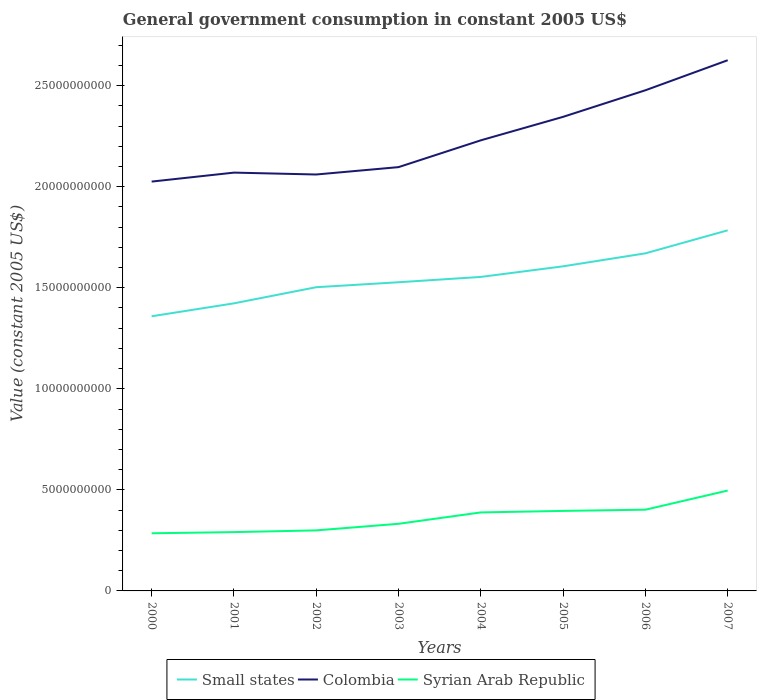How many different coloured lines are there?
Provide a short and direct response. 3. Does the line corresponding to Syrian Arab Republic intersect with the line corresponding to Small states?
Ensure brevity in your answer.  No. Across all years, what is the maximum government conusmption in Small states?
Your answer should be compact. 1.36e+1. What is the total government conusmption in Syrian Arab Republic in the graph?
Keep it short and to the point. -1.35e+08. What is the difference between the highest and the second highest government conusmption in Colombia?
Make the answer very short. 6.00e+09. What is the difference between the highest and the lowest government conusmption in Syrian Arab Republic?
Your answer should be very brief. 4. Is the government conusmption in Syrian Arab Republic strictly greater than the government conusmption in Colombia over the years?
Offer a terse response. Yes. What is the difference between two consecutive major ticks on the Y-axis?
Ensure brevity in your answer.  5.00e+09. Does the graph contain any zero values?
Your response must be concise. No. Does the graph contain grids?
Keep it short and to the point. No. Where does the legend appear in the graph?
Offer a terse response. Bottom center. How many legend labels are there?
Your response must be concise. 3. How are the legend labels stacked?
Ensure brevity in your answer.  Horizontal. What is the title of the graph?
Offer a very short reply. General government consumption in constant 2005 US$. Does "Germany" appear as one of the legend labels in the graph?
Provide a short and direct response. No. What is the label or title of the X-axis?
Offer a terse response. Years. What is the label or title of the Y-axis?
Your answer should be very brief. Value (constant 2005 US$). What is the Value (constant 2005 US$) in Small states in 2000?
Provide a succinct answer. 1.36e+1. What is the Value (constant 2005 US$) in Colombia in 2000?
Your answer should be very brief. 2.03e+1. What is the Value (constant 2005 US$) of Syrian Arab Republic in 2000?
Offer a very short reply. 2.85e+09. What is the Value (constant 2005 US$) of Small states in 2001?
Offer a very short reply. 1.42e+1. What is the Value (constant 2005 US$) of Colombia in 2001?
Provide a succinct answer. 2.07e+1. What is the Value (constant 2005 US$) in Syrian Arab Republic in 2001?
Offer a terse response. 2.91e+09. What is the Value (constant 2005 US$) of Small states in 2002?
Offer a terse response. 1.50e+1. What is the Value (constant 2005 US$) of Colombia in 2002?
Make the answer very short. 2.06e+1. What is the Value (constant 2005 US$) of Syrian Arab Republic in 2002?
Ensure brevity in your answer.  2.99e+09. What is the Value (constant 2005 US$) of Small states in 2003?
Give a very brief answer. 1.53e+1. What is the Value (constant 2005 US$) of Colombia in 2003?
Your answer should be very brief. 2.10e+1. What is the Value (constant 2005 US$) in Syrian Arab Republic in 2003?
Your response must be concise. 3.32e+09. What is the Value (constant 2005 US$) in Small states in 2004?
Your answer should be very brief. 1.55e+1. What is the Value (constant 2005 US$) of Colombia in 2004?
Provide a short and direct response. 2.23e+1. What is the Value (constant 2005 US$) of Syrian Arab Republic in 2004?
Ensure brevity in your answer.  3.88e+09. What is the Value (constant 2005 US$) of Small states in 2005?
Make the answer very short. 1.61e+1. What is the Value (constant 2005 US$) in Colombia in 2005?
Provide a succinct answer. 2.35e+1. What is the Value (constant 2005 US$) in Syrian Arab Republic in 2005?
Your answer should be very brief. 3.96e+09. What is the Value (constant 2005 US$) of Small states in 2006?
Provide a short and direct response. 1.67e+1. What is the Value (constant 2005 US$) of Colombia in 2006?
Provide a succinct answer. 2.48e+1. What is the Value (constant 2005 US$) of Syrian Arab Republic in 2006?
Keep it short and to the point. 4.02e+09. What is the Value (constant 2005 US$) in Small states in 2007?
Give a very brief answer. 1.78e+1. What is the Value (constant 2005 US$) of Colombia in 2007?
Provide a short and direct response. 2.63e+1. What is the Value (constant 2005 US$) of Syrian Arab Republic in 2007?
Your answer should be very brief. 4.97e+09. Across all years, what is the maximum Value (constant 2005 US$) in Small states?
Offer a very short reply. 1.78e+1. Across all years, what is the maximum Value (constant 2005 US$) of Colombia?
Keep it short and to the point. 2.63e+1. Across all years, what is the maximum Value (constant 2005 US$) in Syrian Arab Republic?
Your answer should be compact. 4.97e+09. Across all years, what is the minimum Value (constant 2005 US$) of Small states?
Give a very brief answer. 1.36e+1. Across all years, what is the minimum Value (constant 2005 US$) of Colombia?
Your answer should be compact. 2.03e+1. Across all years, what is the minimum Value (constant 2005 US$) of Syrian Arab Republic?
Make the answer very short. 2.85e+09. What is the total Value (constant 2005 US$) of Small states in the graph?
Provide a short and direct response. 1.24e+11. What is the total Value (constant 2005 US$) of Colombia in the graph?
Keep it short and to the point. 1.79e+11. What is the total Value (constant 2005 US$) in Syrian Arab Republic in the graph?
Provide a succinct answer. 2.89e+1. What is the difference between the Value (constant 2005 US$) of Small states in 2000 and that in 2001?
Make the answer very short. -6.40e+08. What is the difference between the Value (constant 2005 US$) of Colombia in 2000 and that in 2001?
Your answer should be compact. -4.44e+08. What is the difference between the Value (constant 2005 US$) in Syrian Arab Republic in 2000 and that in 2001?
Provide a succinct answer. -5.79e+07. What is the difference between the Value (constant 2005 US$) in Small states in 2000 and that in 2002?
Offer a very short reply. -1.44e+09. What is the difference between the Value (constant 2005 US$) in Colombia in 2000 and that in 2002?
Provide a succinct answer. -3.51e+08. What is the difference between the Value (constant 2005 US$) in Syrian Arab Republic in 2000 and that in 2002?
Ensure brevity in your answer.  -1.43e+08. What is the difference between the Value (constant 2005 US$) in Small states in 2000 and that in 2003?
Keep it short and to the point. -1.68e+09. What is the difference between the Value (constant 2005 US$) in Colombia in 2000 and that in 2003?
Give a very brief answer. -7.15e+08. What is the difference between the Value (constant 2005 US$) in Syrian Arab Republic in 2000 and that in 2003?
Ensure brevity in your answer.  -4.69e+08. What is the difference between the Value (constant 2005 US$) in Small states in 2000 and that in 2004?
Provide a short and direct response. -1.95e+09. What is the difference between the Value (constant 2005 US$) of Colombia in 2000 and that in 2004?
Provide a succinct answer. -2.04e+09. What is the difference between the Value (constant 2005 US$) of Syrian Arab Republic in 2000 and that in 2004?
Your answer should be compact. -1.03e+09. What is the difference between the Value (constant 2005 US$) of Small states in 2000 and that in 2005?
Ensure brevity in your answer.  -2.47e+09. What is the difference between the Value (constant 2005 US$) of Colombia in 2000 and that in 2005?
Your answer should be very brief. -3.20e+09. What is the difference between the Value (constant 2005 US$) in Syrian Arab Republic in 2000 and that in 2005?
Give a very brief answer. -1.11e+09. What is the difference between the Value (constant 2005 US$) of Small states in 2000 and that in 2006?
Ensure brevity in your answer.  -3.11e+09. What is the difference between the Value (constant 2005 US$) in Colombia in 2000 and that in 2006?
Keep it short and to the point. -4.52e+09. What is the difference between the Value (constant 2005 US$) in Syrian Arab Republic in 2000 and that in 2006?
Your response must be concise. -1.17e+09. What is the difference between the Value (constant 2005 US$) in Small states in 2000 and that in 2007?
Keep it short and to the point. -4.25e+09. What is the difference between the Value (constant 2005 US$) of Colombia in 2000 and that in 2007?
Your response must be concise. -6.00e+09. What is the difference between the Value (constant 2005 US$) in Syrian Arab Republic in 2000 and that in 2007?
Keep it short and to the point. -2.11e+09. What is the difference between the Value (constant 2005 US$) in Small states in 2001 and that in 2002?
Keep it short and to the point. -7.99e+08. What is the difference between the Value (constant 2005 US$) of Colombia in 2001 and that in 2002?
Keep it short and to the point. 9.31e+07. What is the difference between the Value (constant 2005 US$) in Syrian Arab Republic in 2001 and that in 2002?
Give a very brief answer. -8.54e+07. What is the difference between the Value (constant 2005 US$) of Small states in 2001 and that in 2003?
Provide a short and direct response. -1.04e+09. What is the difference between the Value (constant 2005 US$) in Colombia in 2001 and that in 2003?
Offer a terse response. -2.71e+08. What is the difference between the Value (constant 2005 US$) in Syrian Arab Republic in 2001 and that in 2003?
Provide a succinct answer. -4.11e+08. What is the difference between the Value (constant 2005 US$) of Small states in 2001 and that in 2004?
Give a very brief answer. -1.31e+09. What is the difference between the Value (constant 2005 US$) in Colombia in 2001 and that in 2004?
Your response must be concise. -1.60e+09. What is the difference between the Value (constant 2005 US$) of Syrian Arab Republic in 2001 and that in 2004?
Make the answer very short. -9.74e+08. What is the difference between the Value (constant 2005 US$) of Small states in 2001 and that in 2005?
Make the answer very short. -1.83e+09. What is the difference between the Value (constant 2005 US$) in Colombia in 2001 and that in 2005?
Your answer should be compact. -2.76e+09. What is the difference between the Value (constant 2005 US$) in Syrian Arab Republic in 2001 and that in 2005?
Ensure brevity in your answer.  -1.05e+09. What is the difference between the Value (constant 2005 US$) in Small states in 2001 and that in 2006?
Give a very brief answer. -2.47e+09. What is the difference between the Value (constant 2005 US$) of Colombia in 2001 and that in 2006?
Offer a terse response. -4.07e+09. What is the difference between the Value (constant 2005 US$) of Syrian Arab Republic in 2001 and that in 2006?
Keep it short and to the point. -1.11e+09. What is the difference between the Value (constant 2005 US$) in Small states in 2001 and that in 2007?
Ensure brevity in your answer.  -3.61e+09. What is the difference between the Value (constant 2005 US$) of Colombia in 2001 and that in 2007?
Provide a short and direct response. -5.56e+09. What is the difference between the Value (constant 2005 US$) in Syrian Arab Republic in 2001 and that in 2007?
Provide a short and direct response. -2.06e+09. What is the difference between the Value (constant 2005 US$) of Small states in 2002 and that in 2003?
Provide a succinct answer. -2.45e+08. What is the difference between the Value (constant 2005 US$) of Colombia in 2002 and that in 2003?
Ensure brevity in your answer.  -3.65e+08. What is the difference between the Value (constant 2005 US$) of Syrian Arab Republic in 2002 and that in 2003?
Offer a very short reply. -3.26e+08. What is the difference between the Value (constant 2005 US$) in Small states in 2002 and that in 2004?
Keep it short and to the point. -5.09e+08. What is the difference between the Value (constant 2005 US$) of Colombia in 2002 and that in 2004?
Keep it short and to the point. -1.69e+09. What is the difference between the Value (constant 2005 US$) in Syrian Arab Republic in 2002 and that in 2004?
Offer a terse response. -8.89e+08. What is the difference between the Value (constant 2005 US$) of Small states in 2002 and that in 2005?
Ensure brevity in your answer.  -1.03e+09. What is the difference between the Value (constant 2005 US$) in Colombia in 2002 and that in 2005?
Provide a short and direct response. -2.85e+09. What is the difference between the Value (constant 2005 US$) of Syrian Arab Republic in 2002 and that in 2005?
Provide a short and direct response. -9.64e+08. What is the difference between the Value (constant 2005 US$) of Small states in 2002 and that in 2006?
Make the answer very short. -1.68e+09. What is the difference between the Value (constant 2005 US$) of Colombia in 2002 and that in 2006?
Your answer should be compact. -4.17e+09. What is the difference between the Value (constant 2005 US$) of Syrian Arab Republic in 2002 and that in 2006?
Offer a very short reply. -1.02e+09. What is the difference between the Value (constant 2005 US$) of Small states in 2002 and that in 2007?
Offer a very short reply. -2.81e+09. What is the difference between the Value (constant 2005 US$) of Colombia in 2002 and that in 2007?
Offer a very short reply. -5.65e+09. What is the difference between the Value (constant 2005 US$) of Syrian Arab Republic in 2002 and that in 2007?
Your response must be concise. -1.97e+09. What is the difference between the Value (constant 2005 US$) in Small states in 2003 and that in 2004?
Provide a short and direct response. -2.64e+08. What is the difference between the Value (constant 2005 US$) of Colombia in 2003 and that in 2004?
Provide a short and direct response. -1.33e+09. What is the difference between the Value (constant 2005 US$) in Syrian Arab Republic in 2003 and that in 2004?
Make the answer very short. -5.63e+08. What is the difference between the Value (constant 2005 US$) of Small states in 2003 and that in 2005?
Keep it short and to the point. -7.88e+08. What is the difference between the Value (constant 2005 US$) of Colombia in 2003 and that in 2005?
Your answer should be very brief. -2.49e+09. What is the difference between the Value (constant 2005 US$) of Syrian Arab Republic in 2003 and that in 2005?
Provide a short and direct response. -6.38e+08. What is the difference between the Value (constant 2005 US$) of Small states in 2003 and that in 2006?
Give a very brief answer. -1.43e+09. What is the difference between the Value (constant 2005 US$) in Colombia in 2003 and that in 2006?
Keep it short and to the point. -3.80e+09. What is the difference between the Value (constant 2005 US$) of Syrian Arab Republic in 2003 and that in 2006?
Provide a short and direct response. -6.98e+08. What is the difference between the Value (constant 2005 US$) in Small states in 2003 and that in 2007?
Your response must be concise. -2.57e+09. What is the difference between the Value (constant 2005 US$) in Colombia in 2003 and that in 2007?
Make the answer very short. -5.29e+09. What is the difference between the Value (constant 2005 US$) in Syrian Arab Republic in 2003 and that in 2007?
Your response must be concise. -1.64e+09. What is the difference between the Value (constant 2005 US$) of Small states in 2004 and that in 2005?
Your response must be concise. -5.24e+08. What is the difference between the Value (constant 2005 US$) in Colombia in 2004 and that in 2005?
Provide a short and direct response. -1.16e+09. What is the difference between the Value (constant 2005 US$) of Syrian Arab Republic in 2004 and that in 2005?
Offer a very short reply. -7.47e+07. What is the difference between the Value (constant 2005 US$) of Small states in 2004 and that in 2006?
Provide a short and direct response. -1.17e+09. What is the difference between the Value (constant 2005 US$) of Colombia in 2004 and that in 2006?
Provide a short and direct response. -2.48e+09. What is the difference between the Value (constant 2005 US$) of Syrian Arab Republic in 2004 and that in 2006?
Make the answer very short. -1.35e+08. What is the difference between the Value (constant 2005 US$) in Small states in 2004 and that in 2007?
Ensure brevity in your answer.  -2.31e+09. What is the difference between the Value (constant 2005 US$) of Colombia in 2004 and that in 2007?
Make the answer very short. -3.96e+09. What is the difference between the Value (constant 2005 US$) of Syrian Arab Republic in 2004 and that in 2007?
Give a very brief answer. -1.08e+09. What is the difference between the Value (constant 2005 US$) of Small states in 2005 and that in 2006?
Keep it short and to the point. -6.42e+08. What is the difference between the Value (constant 2005 US$) of Colombia in 2005 and that in 2006?
Keep it short and to the point. -1.31e+09. What is the difference between the Value (constant 2005 US$) in Syrian Arab Republic in 2005 and that in 2006?
Your answer should be compact. -6.01e+07. What is the difference between the Value (constant 2005 US$) in Small states in 2005 and that in 2007?
Your answer should be compact. -1.78e+09. What is the difference between the Value (constant 2005 US$) of Colombia in 2005 and that in 2007?
Give a very brief answer. -2.80e+09. What is the difference between the Value (constant 2005 US$) in Syrian Arab Republic in 2005 and that in 2007?
Keep it short and to the point. -1.01e+09. What is the difference between the Value (constant 2005 US$) of Small states in 2006 and that in 2007?
Offer a very short reply. -1.14e+09. What is the difference between the Value (constant 2005 US$) of Colombia in 2006 and that in 2007?
Offer a terse response. -1.49e+09. What is the difference between the Value (constant 2005 US$) in Syrian Arab Republic in 2006 and that in 2007?
Make the answer very short. -9.47e+08. What is the difference between the Value (constant 2005 US$) of Small states in 2000 and the Value (constant 2005 US$) of Colombia in 2001?
Ensure brevity in your answer.  -7.11e+09. What is the difference between the Value (constant 2005 US$) in Small states in 2000 and the Value (constant 2005 US$) in Syrian Arab Republic in 2001?
Your answer should be compact. 1.07e+1. What is the difference between the Value (constant 2005 US$) of Colombia in 2000 and the Value (constant 2005 US$) of Syrian Arab Republic in 2001?
Your answer should be very brief. 1.73e+1. What is the difference between the Value (constant 2005 US$) of Small states in 2000 and the Value (constant 2005 US$) of Colombia in 2002?
Provide a short and direct response. -7.01e+09. What is the difference between the Value (constant 2005 US$) in Small states in 2000 and the Value (constant 2005 US$) in Syrian Arab Republic in 2002?
Keep it short and to the point. 1.06e+1. What is the difference between the Value (constant 2005 US$) of Colombia in 2000 and the Value (constant 2005 US$) of Syrian Arab Republic in 2002?
Provide a short and direct response. 1.73e+1. What is the difference between the Value (constant 2005 US$) in Small states in 2000 and the Value (constant 2005 US$) in Colombia in 2003?
Provide a short and direct response. -7.38e+09. What is the difference between the Value (constant 2005 US$) in Small states in 2000 and the Value (constant 2005 US$) in Syrian Arab Republic in 2003?
Make the answer very short. 1.03e+1. What is the difference between the Value (constant 2005 US$) in Colombia in 2000 and the Value (constant 2005 US$) in Syrian Arab Republic in 2003?
Make the answer very short. 1.69e+1. What is the difference between the Value (constant 2005 US$) in Small states in 2000 and the Value (constant 2005 US$) in Colombia in 2004?
Provide a short and direct response. -8.70e+09. What is the difference between the Value (constant 2005 US$) in Small states in 2000 and the Value (constant 2005 US$) in Syrian Arab Republic in 2004?
Your answer should be compact. 9.70e+09. What is the difference between the Value (constant 2005 US$) of Colombia in 2000 and the Value (constant 2005 US$) of Syrian Arab Republic in 2004?
Your response must be concise. 1.64e+1. What is the difference between the Value (constant 2005 US$) in Small states in 2000 and the Value (constant 2005 US$) in Colombia in 2005?
Offer a very short reply. -9.87e+09. What is the difference between the Value (constant 2005 US$) in Small states in 2000 and the Value (constant 2005 US$) in Syrian Arab Republic in 2005?
Give a very brief answer. 9.63e+09. What is the difference between the Value (constant 2005 US$) in Colombia in 2000 and the Value (constant 2005 US$) in Syrian Arab Republic in 2005?
Provide a short and direct response. 1.63e+1. What is the difference between the Value (constant 2005 US$) in Small states in 2000 and the Value (constant 2005 US$) in Colombia in 2006?
Provide a short and direct response. -1.12e+1. What is the difference between the Value (constant 2005 US$) of Small states in 2000 and the Value (constant 2005 US$) of Syrian Arab Republic in 2006?
Keep it short and to the point. 9.57e+09. What is the difference between the Value (constant 2005 US$) in Colombia in 2000 and the Value (constant 2005 US$) in Syrian Arab Republic in 2006?
Ensure brevity in your answer.  1.62e+1. What is the difference between the Value (constant 2005 US$) of Small states in 2000 and the Value (constant 2005 US$) of Colombia in 2007?
Provide a succinct answer. -1.27e+1. What is the difference between the Value (constant 2005 US$) in Small states in 2000 and the Value (constant 2005 US$) in Syrian Arab Republic in 2007?
Offer a very short reply. 8.62e+09. What is the difference between the Value (constant 2005 US$) of Colombia in 2000 and the Value (constant 2005 US$) of Syrian Arab Republic in 2007?
Make the answer very short. 1.53e+1. What is the difference between the Value (constant 2005 US$) in Small states in 2001 and the Value (constant 2005 US$) in Colombia in 2002?
Your answer should be very brief. -6.37e+09. What is the difference between the Value (constant 2005 US$) of Small states in 2001 and the Value (constant 2005 US$) of Syrian Arab Republic in 2002?
Make the answer very short. 1.12e+1. What is the difference between the Value (constant 2005 US$) in Colombia in 2001 and the Value (constant 2005 US$) in Syrian Arab Republic in 2002?
Make the answer very short. 1.77e+1. What is the difference between the Value (constant 2005 US$) of Small states in 2001 and the Value (constant 2005 US$) of Colombia in 2003?
Your answer should be very brief. -6.74e+09. What is the difference between the Value (constant 2005 US$) of Small states in 2001 and the Value (constant 2005 US$) of Syrian Arab Republic in 2003?
Provide a short and direct response. 1.09e+1. What is the difference between the Value (constant 2005 US$) in Colombia in 2001 and the Value (constant 2005 US$) in Syrian Arab Republic in 2003?
Ensure brevity in your answer.  1.74e+1. What is the difference between the Value (constant 2005 US$) of Small states in 2001 and the Value (constant 2005 US$) of Colombia in 2004?
Make the answer very short. -8.07e+09. What is the difference between the Value (constant 2005 US$) of Small states in 2001 and the Value (constant 2005 US$) of Syrian Arab Republic in 2004?
Your answer should be very brief. 1.03e+1. What is the difference between the Value (constant 2005 US$) in Colombia in 2001 and the Value (constant 2005 US$) in Syrian Arab Republic in 2004?
Make the answer very short. 1.68e+1. What is the difference between the Value (constant 2005 US$) in Small states in 2001 and the Value (constant 2005 US$) in Colombia in 2005?
Make the answer very short. -9.23e+09. What is the difference between the Value (constant 2005 US$) in Small states in 2001 and the Value (constant 2005 US$) in Syrian Arab Republic in 2005?
Your answer should be very brief. 1.03e+1. What is the difference between the Value (constant 2005 US$) of Colombia in 2001 and the Value (constant 2005 US$) of Syrian Arab Republic in 2005?
Make the answer very short. 1.67e+1. What is the difference between the Value (constant 2005 US$) in Small states in 2001 and the Value (constant 2005 US$) in Colombia in 2006?
Provide a short and direct response. -1.05e+1. What is the difference between the Value (constant 2005 US$) of Small states in 2001 and the Value (constant 2005 US$) of Syrian Arab Republic in 2006?
Offer a terse response. 1.02e+1. What is the difference between the Value (constant 2005 US$) in Colombia in 2001 and the Value (constant 2005 US$) in Syrian Arab Republic in 2006?
Keep it short and to the point. 1.67e+1. What is the difference between the Value (constant 2005 US$) in Small states in 2001 and the Value (constant 2005 US$) in Colombia in 2007?
Provide a succinct answer. -1.20e+1. What is the difference between the Value (constant 2005 US$) of Small states in 2001 and the Value (constant 2005 US$) of Syrian Arab Republic in 2007?
Provide a short and direct response. 9.26e+09. What is the difference between the Value (constant 2005 US$) in Colombia in 2001 and the Value (constant 2005 US$) in Syrian Arab Republic in 2007?
Your answer should be compact. 1.57e+1. What is the difference between the Value (constant 2005 US$) of Small states in 2002 and the Value (constant 2005 US$) of Colombia in 2003?
Provide a short and direct response. -5.94e+09. What is the difference between the Value (constant 2005 US$) in Small states in 2002 and the Value (constant 2005 US$) in Syrian Arab Republic in 2003?
Make the answer very short. 1.17e+1. What is the difference between the Value (constant 2005 US$) in Colombia in 2002 and the Value (constant 2005 US$) in Syrian Arab Republic in 2003?
Give a very brief answer. 1.73e+1. What is the difference between the Value (constant 2005 US$) in Small states in 2002 and the Value (constant 2005 US$) in Colombia in 2004?
Make the answer very short. -7.27e+09. What is the difference between the Value (constant 2005 US$) of Small states in 2002 and the Value (constant 2005 US$) of Syrian Arab Republic in 2004?
Your answer should be compact. 1.11e+1. What is the difference between the Value (constant 2005 US$) in Colombia in 2002 and the Value (constant 2005 US$) in Syrian Arab Republic in 2004?
Offer a terse response. 1.67e+1. What is the difference between the Value (constant 2005 US$) in Small states in 2002 and the Value (constant 2005 US$) in Colombia in 2005?
Make the answer very short. -8.43e+09. What is the difference between the Value (constant 2005 US$) of Small states in 2002 and the Value (constant 2005 US$) of Syrian Arab Republic in 2005?
Keep it short and to the point. 1.11e+1. What is the difference between the Value (constant 2005 US$) of Colombia in 2002 and the Value (constant 2005 US$) of Syrian Arab Republic in 2005?
Provide a succinct answer. 1.66e+1. What is the difference between the Value (constant 2005 US$) of Small states in 2002 and the Value (constant 2005 US$) of Colombia in 2006?
Offer a very short reply. -9.74e+09. What is the difference between the Value (constant 2005 US$) in Small states in 2002 and the Value (constant 2005 US$) in Syrian Arab Republic in 2006?
Keep it short and to the point. 1.10e+1. What is the difference between the Value (constant 2005 US$) of Colombia in 2002 and the Value (constant 2005 US$) of Syrian Arab Republic in 2006?
Give a very brief answer. 1.66e+1. What is the difference between the Value (constant 2005 US$) of Small states in 2002 and the Value (constant 2005 US$) of Colombia in 2007?
Your response must be concise. -1.12e+1. What is the difference between the Value (constant 2005 US$) of Small states in 2002 and the Value (constant 2005 US$) of Syrian Arab Republic in 2007?
Make the answer very short. 1.01e+1. What is the difference between the Value (constant 2005 US$) of Colombia in 2002 and the Value (constant 2005 US$) of Syrian Arab Republic in 2007?
Offer a very short reply. 1.56e+1. What is the difference between the Value (constant 2005 US$) of Small states in 2003 and the Value (constant 2005 US$) of Colombia in 2004?
Provide a succinct answer. -7.02e+09. What is the difference between the Value (constant 2005 US$) of Small states in 2003 and the Value (constant 2005 US$) of Syrian Arab Republic in 2004?
Make the answer very short. 1.14e+1. What is the difference between the Value (constant 2005 US$) in Colombia in 2003 and the Value (constant 2005 US$) in Syrian Arab Republic in 2004?
Your answer should be compact. 1.71e+1. What is the difference between the Value (constant 2005 US$) in Small states in 2003 and the Value (constant 2005 US$) in Colombia in 2005?
Provide a short and direct response. -8.18e+09. What is the difference between the Value (constant 2005 US$) in Small states in 2003 and the Value (constant 2005 US$) in Syrian Arab Republic in 2005?
Keep it short and to the point. 1.13e+1. What is the difference between the Value (constant 2005 US$) of Colombia in 2003 and the Value (constant 2005 US$) of Syrian Arab Republic in 2005?
Offer a very short reply. 1.70e+1. What is the difference between the Value (constant 2005 US$) of Small states in 2003 and the Value (constant 2005 US$) of Colombia in 2006?
Keep it short and to the point. -9.50e+09. What is the difference between the Value (constant 2005 US$) of Small states in 2003 and the Value (constant 2005 US$) of Syrian Arab Republic in 2006?
Keep it short and to the point. 1.13e+1. What is the difference between the Value (constant 2005 US$) of Colombia in 2003 and the Value (constant 2005 US$) of Syrian Arab Republic in 2006?
Keep it short and to the point. 1.69e+1. What is the difference between the Value (constant 2005 US$) of Small states in 2003 and the Value (constant 2005 US$) of Colombia in 2007?
Offer a very short reply. -1.10e+1. What is the difference between the Value (constant 2005 US$) of Small states in 2003 and the Value (constant 2005 US$) of Syrian Arab Republic in 2007?
Provide a short and direct response. 1.03e+1. What is the difference between the Value (constant 2005 US$) in Colombia in 2003 and the Value (constant 2005 US$) in Syrian Arab Republic in 2007?
Keep it short and to the point. 1.60e+1. What is the difference between the Value (constant 2005 US$) in Small states in 2004 and the Value (constant 2005 US$) in Colombia in 2005?
Provide a short and direct response. -7.92e+09. What is the difference between the Value (constant 2005 US$) in Small states in 2004 and the Value (constant 2005 US$) in Syrian Arab Republic in 2005?
Offer a terse response. 1.16e+1. What is the difference between the Value (constant 2005 US$) in Colombia in 2004 and the Value (constant 2005 US$) in Syrian Arab Republic in 2005?
Make the answer very short. 1.83e+1. What is the difference between the Value (constant 2005 US$) in Small states in 2004 and the Value (constant 2005 US$) in Colombia in 2006?
Keep it short and to the point. -9.23e+09. What is the difference between the Value (constant 2005 US$) in Small states in 2004 and the Value (constant 2005 US$) in Syrian Arab Republic in 2006?
Offer a terse response. 1.15e+1. What is the difference between the Value (constant 2005 US$) in Colombia in 2004 and the Value (constant 2005 US$) in Syrian Arab Republic in 2006?
Offer a very short reply. 1.83e+1. What is the difference between the Value (constant 2005 US$) in Small states in 2004 and the Value (constant 2005 US$) in Colombia in 2007?
Your answer should be very brief. -1.07e+1. What is the difference between the Value (constant 2005 US$) of Small states in 2004 and the Value (constant 2005 US$) of Syrian Arab Republic in 2007?
Provide a short and direct response. 1.06e+1. What is the difference between the Value (constant 2005 US$) of Colombia in 2004 and the Value (constant 2005 US$) of Syrian Arab Republic in 2007?
Your answer should be very brief. 1.73e+1. What is the difference between the Value (constant 2005 US$) of Small states in 2005 and the Value (constant 2005 US$) of Colombia in 2006?
Keep it short and to the point. -8.71e+09. What is the difference between the Value (constant 2005 US$) in Small states in 2005 and the Value (constant 2005 US$) in Syrian Arab Republic in 2006?
Give a very brief answer. 1.20e+1. What is the difference between the Value (constant 2005 US$) of Colombia in 2005 and the Value (constant 2005 US$) of Syrian Arab Republic in 2006?
Your response must be concise. 1.94e+1. What is the difference between the Value (constant 2005 US$) of Small states in 2005 and the Value (constant 2005 US$) of Colombia in 2007?
Your response must be concise. -1.02e+1. What is the difference between the Value (constant 2005 US$) of Small states in 2005 and the Value (constant 2005 US$) of Syrian Arab Republic in 2007?
Your answer should be very brief. 1.11e+1. What is the difference between the Value (constant 2005 US$) in Colombia in 2005 and the Value (constant 2005 US$) in Syrian Arab Republic in 2007?
Keep it short and to the point. 1.85e+1. What is the difference between the Value (constant 2005 US$) in Small states in 2006 and the Value (constant 2005 US$) in Colombia in 2007?
Provide a succinct answer. -9.55e+09. What is the difference between the Value (constant 2005 US$) of Small states in 2006 and the Value (constant 2005 US$) of Syrian Arab Republic in 2007?
Keep it short and to the point. 1.17e+1. What is the difference between the Value (constant 2005 US$) of Colombia in 2006 and the Value (constant 2005 US$) of Syrian Arab Republic in 2007?
Your response must be concise. 1.98e+1. What is the average Value (constant 2005 US$) in Small states per year?
Ensure brevity in your answer.  1.55e+1. What is the average Value (constant 2005 US$) of Colombia per year?
Offer a terse response. 2.24e+1. What is the average Value (constant 2005 US$) in Syrian Arab Republic per year?
Keep it short and to the point. 3.61e+09. In the year 2000, what is the difference between the Value (constant 2005 US$) in Small states and Value (constant 2005 US$) in Colombia?
Give a very brief answer. -6.66e+09. In the year 2000, what is the difference between the Value (constant 2005 US$) of Small states and Value (constant 2005 US$) of Syrian Arab Republic?
Give a very brief answer. 1.07e+1. In the year 2000, what is the difference between the Value (constant 2005 US$) of Colombia and Value (constant 2005 US$) of Syrian Arab Republic?
Ensure brevity in your answer.  1.74e+1. In the year 2001, what is the difference between the Value (constant 2005 US$) of Small states and Value (constant 2005 US$) of Colombia?
Offer a terse response. -6.47e+09. In the year 2001, what is the difference between the Value (constant 2005 US$) of Small states and Value (constant 2005 US$) of Syrian Arab Republic?
Your answer should be compact. 1.13e+1. In the year 2001, what is the difference between the Value (constant 2005 US$) in Colombia and Value (constant 2005 US$) in Syrian Arab Republic?
Your answer should be compact. 1.78e+1. In the year 2002, what is the difference between the Value (constant 2005 US$) of Small states and Value (constant 2005 US$) of Colombia?
Offer a very short reply. -5.58e+09. In the year 2002, what is the difference between the Value (constant 2005 US$) of Small states and Value (constant 2005 US$) of Syrian Arab Republic?
Offer a very short reply. 1.20e+1. In the year 2002, what is the difference between the Value (constant 2005 US$) in Colombia and Value (constant 2005 US$) in Syrian Arab Republic?
Provide a short and direct response. 1.76e+1. In the year 2003, what is the difference between the Value (constant 2005 US$) in Small states and Value (constant 2005 US$) in Colombia?
Provide a succinct answer. -5.70e+09. In the year 2003, what is the difference between the Value (constant 2005 US$) of Small states and Value (constant 2005 US$) of Syrian Arab Republic?
Offer a very short reply. 1.20e+1. In the year 2003, what is the difference between the Value (constant 2005 US$) in Colombia and Value (constant 2005 US$) in Syrian Arab Republic?
Keep it short and to the point. 1.76e+1. In the year 2004, what is the difference between the Value (constant 2005 US$) in Small states and Value (constant 2005 US$) in Colombia?
Ensure brevity in your answer.  -6.76e+09. In the year 2004, what is the difference between the Value (constant 2005 US$) of Small states and Value (constant 2005 US$) of Syrian Arab Republic?
Provide a short and direct response. 1.17e+1. In the year 2004, what is the difference between the Value (constant 2005 US$) in Colombia and Value (constant 2005 US$) in Syrian Arab Republic?
Your answer should be compact. 1.84e+1. In the year 2005, what is the difference between the Value (constant 2005 US$) in Small states and Value (constant 2005 US$) in Colombia?
Make the answer very short. -7.40e+09. In the year 2005, what is the difference between the Value (constant 2005 US$) in Small states and Value (constant 2005 US$) in Syrian Arab Republic?
Your answer should be very brief. 1.21e+1. In the year 2005, what is the difference between the Value (constant 2005 US$) in Colombia and Value (constant 2005 US$) in Syrian Arab Republic?
Your answer should be compact. 1.95e+1. In the year 2006, what is the difference between the Value (constant 2005 US$) in Small states and Value (constant 2005 US$) in Colombia?
Offer a terse response. -8.07e+09. In the year 2006, what is the difference between the Value (constant 2005 US$) of Small states and Value (constant 2005 US$) of Syrian Arab Republic?
Your answer should be compact. 1.27e+1. In the year 2006, what is the difference between the Value (constant 2005 US$) in Colombia and Value (constant 2005 US$) in Syrian Arab Republic?
Offer a terse response. 2.08e+1. In the year 2007, what is the difference between the Value (constant 2005 US$) of Small states and Value (constant 2005 US$) of Colombia?
Ensure brevity in your answer.  -8.41e+09. In the year 2007, what is the difference between the Value (constant 2005 US$) of Small states and Value (constant 2005 US$) of Syrian Arab Republic?
Make the answer very short. 1.29e+1. In the year 2007, what is the difference between the Value (constant 2005 US$) in Colombia and Value (constant 2005 US$) in Syrian Arab Republic?
Offer a terse response. 2.13e+1. What is the ratio of the Value (constant 2005 US$) in Small states in 2000 to that in 2001?
Keep it short and to the point. 0.95. What is the ratio of the Value (constant 2005 US$) of Colombia in 2000 to that in 2001?
Give a very brief answer. 0.98. What is the ratio of the Value (constant 2005 US$) in Syrian Arab Republic in 2000 to that in 2001?
Offer a very short reply. 0.98. What is the ratio of the Value (constant 2005 US$) in Small states in 2000 to that in 2002?
Ensure brevity in your answer.  0.9. What is the ratio of the Value (constant 2005 US$) in Syrian Arab Republic in 2000 to that in 2002?
Your response must be concise. 0.95. What is the ratio of the Value (constant 2005 US$) of Small states in 2000 to that in 2003?
Ensure brevity in your answer.  0.89. What is the ratio of the Value (constant 2005 US$) of Colombia in 2000 to that in 2003?
Your response must be concise. 0.97. What is the ratio of the Value (constant 2005 US$) of Syrian Arab Republic in 2000 to that in 2003?
Your response must be concise. 0.86. What is the ratio of the Value (constant 2005 US$) in Small states in 2000 to that in 2004?
Give a very brief answer. 0.87. What is the ratio of the Value (constant 2005 US$) of Colombia in 2000 to that in 2004?
Ensure brevity in your answer.  0.91. What is the ratio of the Value (constant 2005 US$) in Syrian Arab Republic in 2000 to that in 2004?
Offer a terse response. 0.73. What is the ratio of the Value (constant 2005 US$) of Small states in 2000 to that in 2005?
Ensure brevity in your answer.  0.85. What is the ratio of the Value (constant 2005 US$) of Colombia in 2000 to that in 2005?
Your answer should be very brief. 0.86. What is the ratio of the Value (constant 2005 US$) in Syrian Arab Republic in 2000 to that in 2005?
Your answer should be compact. 0.72. What is the ratio of the Value (constant 2005 US$) of Small states in 2000 to that in 2006?
Offer a terse response. 0.81. What is the ratio of the Value (constant 2005 US$) of Colombia in 2000 to that in 2006?
Your answer should be compact. 0.82. What is the ratio of the Value (constant 2005 US$) of Syrian Arab Republic in 2000 to that in 2006?
Ensure brevity in your answer.  0.71. What is the ratio of the Value (constant 2005 US$) in Small states in 2000 to that in 2007?
Keep it short and to the point. 0.76. What is the ratio of the Value (constant 2005 US$) in Colombia in 2000 to that in 2007?
Give a very brief answer. 0.77. What is the ratio of the Value (constant 2005 US$) in Syrian Arab Republic in 2000 to that in 2007?
Provide a short and direct response. 0.57. What is the ratio of the Value (constant 2005 US$) in Small states in 2001 to that in 2002?
Make the answer very short. 0.95. What is the ratio of the Value (constant 2005 US$) of Colombia in 2001 to that in 2002?
Your response must be concise. 1. What is the ratio of the Value (constant 2005 US$) of Syrian Arab Republic in 2001 to that in 2002?
Offer a very short reply. 0.97. What is the ratio of the Value (constant 2005 US$) in Small states in 2001 to that in 2003?
Give a very brief answer. 0.93. What is the ratio of the Value (constant 2005 US$) in Colombia in 2001 to that in 2003?
Your response must be concise. 0.99. What is the ratio of the Value (constant 2005 US$) of Syrian Arab Republic in 2001 to that in 2003?
Provide a short and direct response. 0.88. What is the ratio of the Value (constant 2005 US$) in Small states in 2001 to that in 2004?
Offer a very short reply. 0.92. What is the ratio of the Value (constant 2005 US$) of Colombia in 2001 to that in 2004?
Keep it short and to the point. 0.93. What is the ratio of the Value (constant 2005 US$) in Syrian Arab Republic in 2001 to that in 2004?
Your response must be concise. 0.75. What is the ratio of the Value (constant 2005 US$) in Small states in 2001 to that in 2005?
Offer a terse response. 0.89. What is the ratio of the Value (constant 2005 US$) in Colombia in 2001 to that in 2005?
Offer a very short reply. 0.88. What is the ratio of the Value (constant 2005 US$) of Syrian Arab Republic in 2001 to that in 2005?
Provide a short and direct response. 0.73. What is the ratio of the Value (constant 2005 US$) of Small states in 2001 to that in 2006?
Offer a terse response. 0.85. What is the ratio of the Value (constant 2005 US$) of Colombia in 2001 to that in 2006?
Offer a very short reply. 0.84. What is the ratio of the Value (constant 2005 US$) of Syrian Arab Republic in 2001 to that in 2006?
Provide a short and direct response. 0.72. What is the ratio of the Value (constant 2005 US$) in Small states in 2001 to that in 2007?
Provide a short and direct response. 0.8. What is the ratio of the Value (constant 2005 US$) in Colombia in 2001 to that in 2007?
Keep it short and to the point. 0.79. What is the ratio of the Value (constant 2005 US$) in Syrian Arab Republic in 2001 to that in 2007?
Make the answer very short. 0.59. What is the ratio of the Value (constant 2005 US$) of Small states in 2002 to that in 2003?
Offer a very short reply. 0.98. What is the ratio of the Value (constant 2005 US$) in Colombia in 2002 to that in 2003?
Offer a terse response. 0.98. What is the ratio of the Value (constant 2005 US$) of Syrian Arab Republic in 2002 to that in 2003?
Give a very brief answer. 0.9. What is the ratio of the Value (constant 2005 US$) of Small states in 2002 to that in 2004?
Make the answer very short. 0.97. What is the ratio of the Value (constant 2005 US$) in Colombia in 2002 to that in 2004?
Make the answer very short. 0.92. What is the ratio of the Value (constant 2005 US$) of Syrian Arab Republic in 2002 to that in 2004?
Provide a succinct answer. 0.77. What is the ratio of the Value (constant 2005 US$) in Small states in 2002 to that in 2005?
Keep it short and to the point. 0.94. What is the ratio of the Value (constant 2005 US$) of Colombia in 2002 to that in 2005?
Give a very brief answer. 0.88. What is the ratio of the Value (constant 2005 US$) of Syrian Arab Republic in 2002 to that in 2005?
Your answer should be compact. 0.76. What is the ratio of the Value (constant 2005 US$) in Small states in 2002 to that in 2006?
Provide a short and direct response. 0.9. What is the ratio of the Value (constant 2005 US$) of Colombia in 2002 to that in 2006?
Keep it short and to the point. 0.83. What is the ratio of the Value (constant 2005 US$) of Syrian Arab Republic in 2002 to that in 2006?
Ensure brevity in your answer.  0.75. What is the ratio of the Value (constant 2005 US$) in Small states in 2002 to that in 2007?
Your answer should be compact. 0.84. What is the ratio of the Value (constant 2005 US$) of Colombia in 2002 to that in 2007?
Keep it short and to the point. 0.78. What is the ratio of the Value (constant 2005 US$) in Syrian Arab Republic in 2002 to that in 2007?
Keep it short and to the point. 0.6. What is the ratio of the Value (constant 2005 US$) of Small states in 2003 to that in 2004?
Make the answer very short. 0.98. What is the ratio of the Value (constant 2005 US$) of Colombia in 2003 to that in 2004?
Your answer should be very brief. 0.94. What is the ratio of the Value (constant 2005 US$) of Syrian Arab Republic in 2003 to that in 2004?
Your response must be concise. 0.85. What is the ratio of the Value (constant 2005 US$) in Small states in 2003 to that in 2005?
Make the answer very short. 0.95. What is the ratio of the Value (constant 2005 US$) of Colombia in 2003 to that in 2005?
Keep it short and to the point. 0.89. What is the ratio of the Value (constant 2005 US$) of Syrian Arab Republic in 2003 to that in 2005?
Ensure brevity in your answer.  0.84. What is the ratio of the Value (constant 2005 US$) in Small states in 2003 to that in 2006?
Make the answer very short. 0.91. What is the ratio of the Value (constant 2005 US$) in Colombia in 2003 to that in 2006?
Provide a succinct answer. 0.85. What is the ratio of the Value (constant 2005 US$) of Syrian Arab Republic in 2003 to that in 2006?
Your answer should be very brief. 0.83. What is the ratio of the Value (constant 2005 US$) in Small states in 2003 to that in 2007?
Provide a succinct answer. 0.86. What is the ratio of the Value (constant 2005 US$) of Colombia in 2003 to that in 2007?
Offer a terse response. 0.8. What is the ratio of the Value (constant 2005 US$) of Syrian Arab Republic in 2003 to that in 2007?
Your answer should be compact. 0.67. What is the ratio of the Value (constant 2005 US$) in Small states in 2004 to that in 2005?
Provide a short and direct response. 0.97. What is the ratio of the Value (constant 2005 US$) of Colombia in 2004 to that in 2005?
Your answer should be very brief. 0.95. What is the ratio of the Value (constant 2005 US$) of Syrian Arab Republic in 2004 to that in 2005?
Provide a succinct answer. 0.98. What is the ratio of the Value (constant 2005 US$) of Small states in 2004 to that in 2006?
Your answer should be compact. 0.93. What is the ratio of the Value (constant 2005 US$) of Syrian Arab Republic in 2004 to that in 2006?
Provide a succinct answer. 0.97. What is the ratio of the Value (constant 2005 US$) in Small states in 2004 to that in 2007?
Offer a very short reply. 0.87. What is the ratio of the Value (constant 2005 US$) in Colombia in 2004 to that in 2007?
Your response must be concise. 0.85. What is the ratio of the Value (constant 2005 US$) in Syrian Arab Republic in 2004 to that in 2007?
Make the answer very short. 0.78. What is the ratio of the Value (constant 2005 US$) of Small states in 2005 to that in 2006?
Give a very brief answer. 0.96. What is the ratio of the Value (constant 2005 US$) of Colombia in 2005 to that in 2006?
Your response must be concise. 0.95. What is the ratio of the Value (constant 2005 US$) of Syrian Arab Republic in 2005 to that in 2006?
Keep it short and to the point. 0.98. What is the ratio of the Value (constant 2005 US$) in Small states in 2005 to that in 2007?
Ensure brevity in your answer.  0.9. What is the ratio of the Value (constant 2005 US$) of Colombia in 2005 to that in 2007?
Your answer should be compact. 0.89. What is the ratio of the Value (constant 2005 US$) of Syrian Arab Republic in 2005 to that in 2007?
Provide a short and direct response. 0.8. What is the ratio of the Value (constant 2005 US$) in Small states in 2006 to that in 2007?
Provide a succinct answer. 0.94. What is the ratio of the Value (constant 2005 US$) in Colombia in 2006 to that in 2007?
Ensure brevity in your answer.  0.94. What is the ratio of the Value (constant 2005 US$) in Syrian Arab Republic in 2006 to that in 2007?
Provide a succinct answer. 0.81. What is the difference between the highest and the second highest Value (constant 2005 US$) in Small states?
Keep it short and to the point. 1.14e+09. What is the difference between the highest and the second highest Value (constant 2005 US$) of Colombia?
Keep it short and to the point. 1.49e+09. What is the difference between the highest and the second highest Value (constant 2005 US$) in Syrian Arab Republic?
Provide a succinct answer. 9.47e+08. What is the difference between the highest and the lowest Value (constant 2005 US$) of Small states?
Your answer should be compact. 4.25e+09. What is the difference between the highest and the lowest Value (constant 2005 US$) of Colombia?
Provide a short and direct response. 6.00e+09. What is the difference between the highest and the lowest Value (constant 2005 US$) in Syrian Arab Republic?
Your answer should be compact. 2.11e+09. 